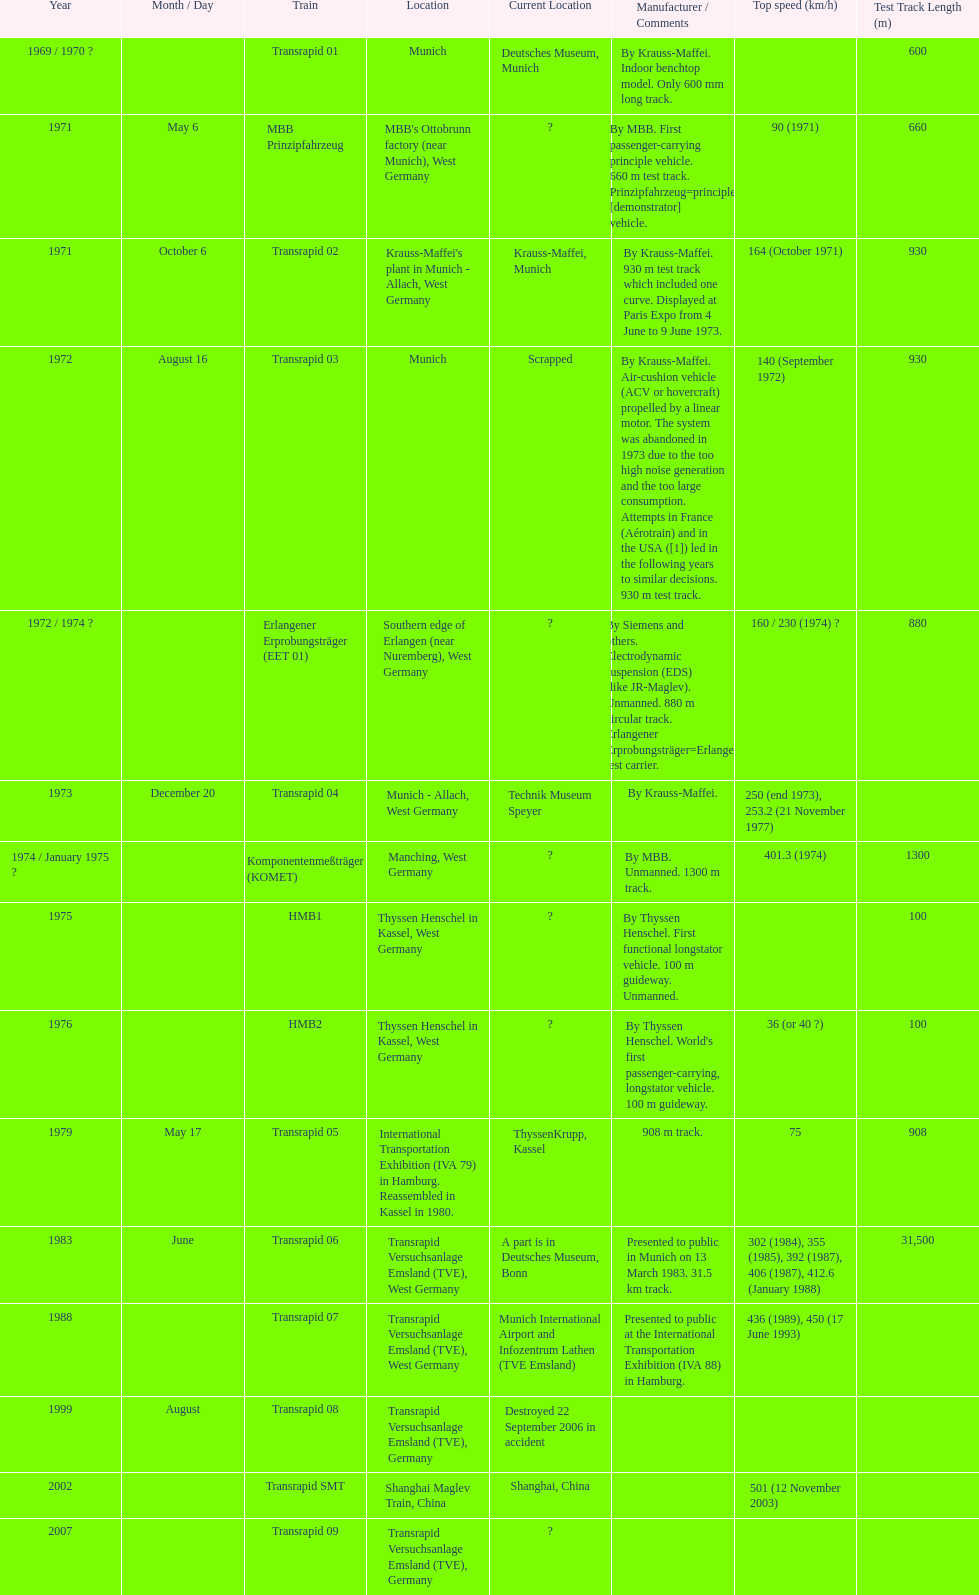Give me the full table as a dictionary. {'header': ['Year', 'Month / Day', 'Train', 'Location', 'Current Location', 'Manufacturer / Comments', 'Top speed (km/h)', 'Test Track Length (m)'], 'rows': [['1969 / 1970 ?', '', 'Transrapid 01', 'Munich', 'Deutsches Museum, Munich', 'By Krauss-Maffei. Indoor benchtop model. Only 600 mm long track.', '', '600'], ['1971', 'May 6', 'MBB Prinzipfahrzeug', "MBB's Ottobrunn factory (near Munich), West Germany", '?', 'By MBB. First passenger-carrying principle vehicle. 660 m test track. Prinzipfahrzeug=principle [demonstrator] vehicle.', '90 (1971)', '660'], ['1971', 'October 6', 'Transrapid 02', "Krauss-Maffei's plant in Munich - Allach, West Germany", 'Krauss-Maffei, Munich', 'By Krauss-Maffei. 930 m test track which included one curve. Displayed at Paris Expo from 4 June to 9 June 1973.', '164 (October 1971)', '930'], ['1972', 'August 16', 'Transrapid 03', 'Munich', 'Scrapped', 'By Krauss-Maffei. Air-cushion vehicle (ACV or hovercraft) propelled by a linear motor. The system was abandoned in 1973 due to the too high noise generation and the too large consumption. Attempts in France (Aérotrain) and in the USA ([1]) led in the following years to similar decisions. 930 m test track.', '140 (September 1972)', '930'], ['1972 / 1974 ?', '', 'Erlangener Erprobungsträger (EET 01)', 'Southern edge of Erlangen (near Nuremberg), West Germany', '?', 'By Siemens and others. Electrodynamic suspension (EDS) (like JR-Maglev). Unmanned. 880 m circular track. Erlangener Erprobungsträger=Erlangen test carrier.', '160 / 230 (1974)\xa0?', '880'], ['1973', 'December 20', 'Transrapid 04', 'Munich - Allach, West Germany', 'Technik Museum Speyer', 'By Krauss-Maffei.', '250 (end 1973), 253.2 (21 November 1977)', ''], ['1974 / January 1975 ?', '', 'Komponentenmeßträger (KOMET)', 'Manching, West Germany', '?', 'By MBB. Unmanned. 1300 m track.', '401.3 (1974)', '1300'], ['1975', '', 'HMB1', 'Thyssen Henschel in Kassel, West Germany', '?', 'By Thyssen Henschel. First functional longstator vehicle. 100 m guideway. Unmanned.', '', '100'], ['1976', '', 'HMB2', 'Thyssen Henschel in Kassel, West Germany', '?', "By Thyssen Henschel. World's first passenger-carrying, longstator vehicle. 100 m guideway.", '36 (or 40\xa0?)', '100'], ['1979', 'May 17', 'Transrapid 05', 'International Transportation Exhibition (IVA 79) in Hamburg. Reassembled in Kassel in 1980.', 'ThyssenKrupp, Kassel', '908 m track.', '75', '908'], ['1983', 'June', 'Transrapid 06', 'Transrapid Versuchsanlage Emsland (TVE), West Germany', 'A part is in Deutsches Museum, Bonn', 'Presented to public in Munich on 13 March 1983. 31.5 km track.', '302 (1984), 355 (1985), 392 (1987), 406 (1987), 412.6 (January 1988)', '31,500'], ['1988', '', 'Transrapid 07', 'Transrapid Versuchsanlage Emsland (TVE), West Germany', 'Munich International Airport and Infozentrum Lathen (TVE Emsland)', 'Presented to public at the International Transportation Exhibition (IVA 88) in Hamburg.', '436 (1989), 450 (17 June 1993)', ''], ['1999', 'August', 'Transrapid 08', 'Transrapid Versuchsanlage Emsland (TVE), Germany', 'Destroyed 22 September 2006 in accident', '', '', ''], ['2002', '', 'Transrapid SMT', 'Shanghai Maglev Train, China', 'Shanghai, China', '', '501 (12 November 2003)', ''], ['2007', '', 'Transrapid 09', 'Transrapid Versuchsanlage Emsland (TVE), Germany', '?', '', '', '']]} What is the only train to reach a top speed of 500 or more? Transrapid SMT. 